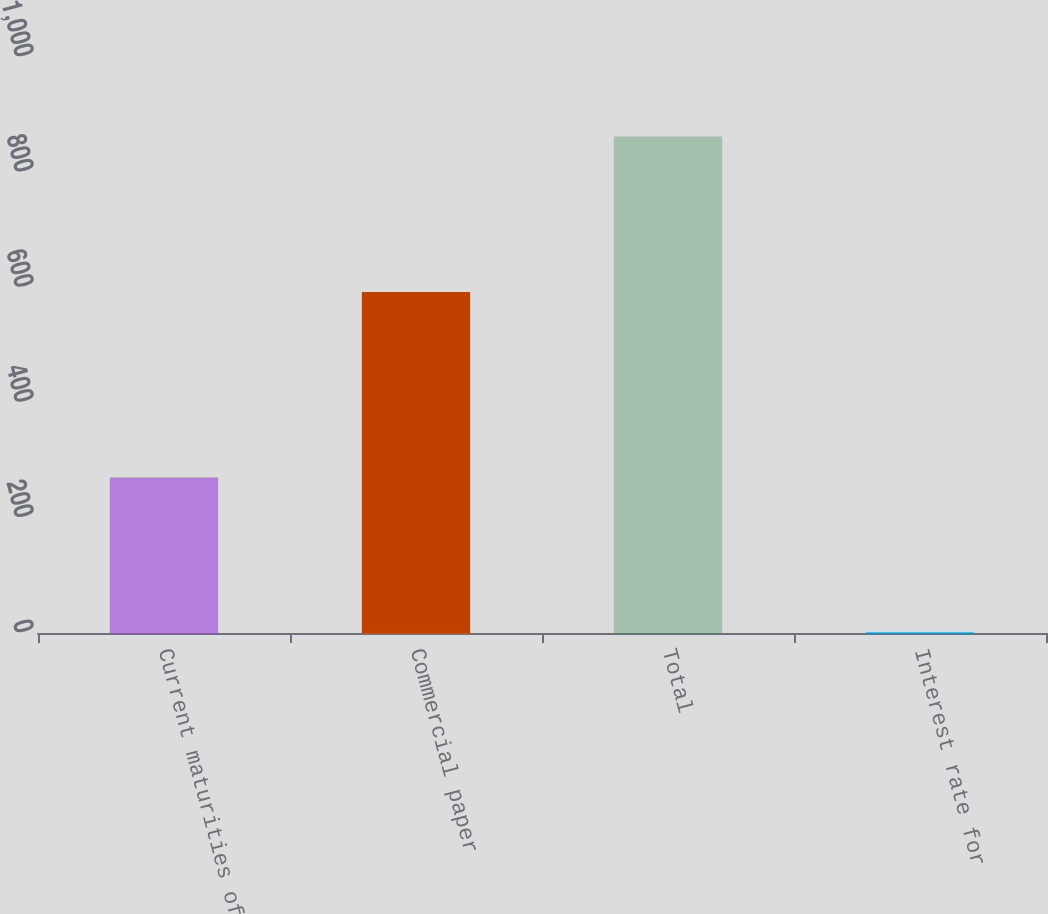Convert chart. <chart><loc_0><loc_0><loc_500><loc_500><bar_chart><fcel>Current maturities of<fcel>Commercial paper<fcel>Total<fcel>Interest rate for<nl><fcel>270<fcel>592<fcel>862<fcel>1.1<nl></chart> 